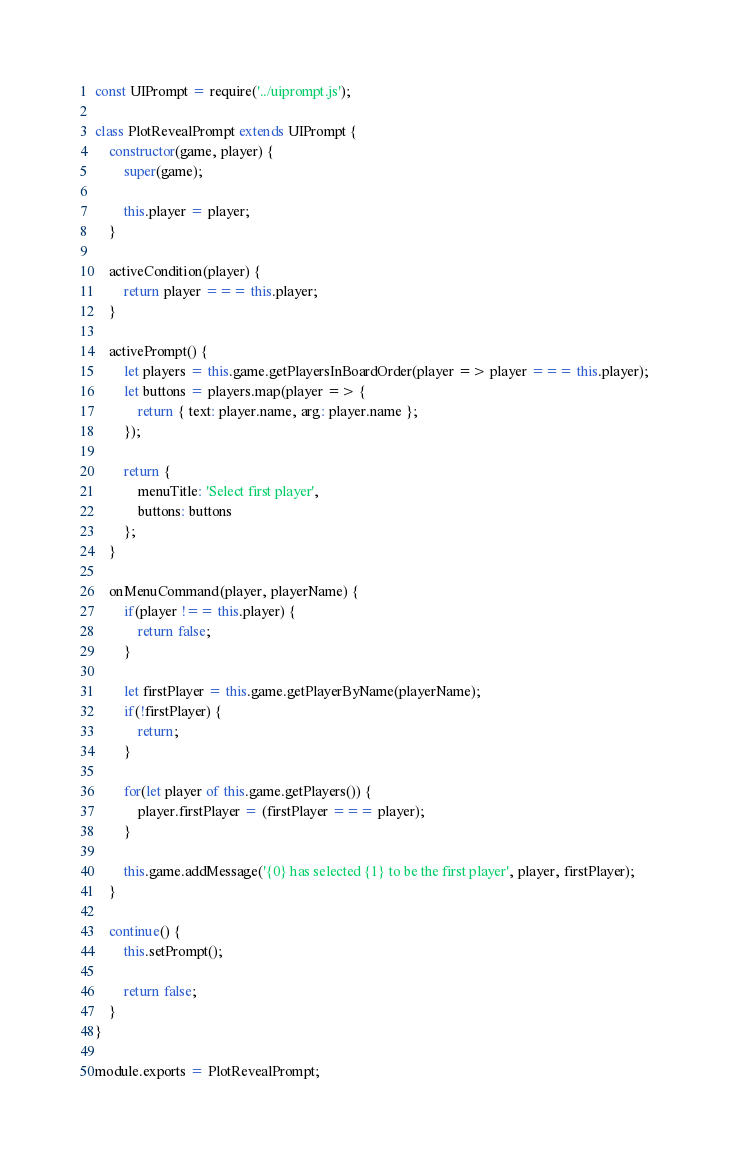Convert code to text. <code><loc_0><loc_0><loc_500><loc_500><_JavaScript_>const UIPrompt = require('../uiprompt.js');

class PlotRevealPrompt extends UIPrompt {
    constructor(game, player) {
        super(game);

        this.player = player;
    }

    activeCondition(player) {
        return player === this.player;
    }

    activePrompt() {
        let players = this.game.getPlayersInBoardOrder(player => player === this.player);
        let buttons = players.map(player => {
            return { text: player.name, arg: player.name };
        });

        return {
            menuTitle: 'Select first player',
            buttons: buttons
        };
    }

    onMenuCommand(player, playerName) {
        if(player !== this.player) {
            return false;
        }

        let firstPlayer = this.game.getPlayerByName(playerName);
        if(!firstPlayer) {
            return;
        }

        for(let player of this.game.getPlayers()) {
            player.firstPlayer = (firstPlayer === player);
        }

        this.game.addMessage('{0} has selected {1} to be the first player', player, firstPlayer);
    }

    continue() {
        this.setPrompt();

        return false;
    }
}

module.exports = PlotRevealPrompt;
</code> 